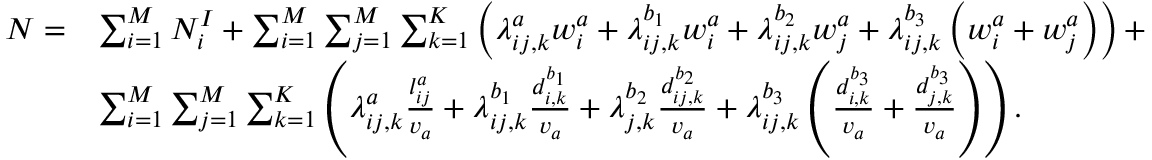Convert formula to latex. <formula><loc_0><loc_0><loc_500><loc_500>\begin{array} { r l } { N = } & { \sum _ { i = 1 } ^ { M } N _ { i } ^ { I } + \sum _ { i = 1 } ^ { M } \sum _ { j = 1 } ^ { M } \sum _ { k = 1 } ^ { K } \left ( \lambda _ { i j , k } ^ { a } w _ { i } ^ { a } + \lambda _ { i j , k } ^ { b _ { 1 } } w _ { i } ^ { a } + \lambda _ { i j , k } ^ { b _ { 2 } } w _ { j } ^ { a } + \lambda _ { i j , k } ^ { b _ { 3 } } \left ( w _ { i } ^ { a } + w _ { j } ^ { a } \right ) \right ) + } \\ & { \sum _ { i = 1 } ^ { M } \sum _ { j = 1 } ^ { M } \sum _ { k = 1 } ^ { K } \left ( \lambda _ { i j , k } ^ { a } \frac { l _ { i j } ^ { a } } { v _ { a } } + \lambda _ { i j , k } ^ { b _ { 1 } } \frac { d _ { i , k } ^ { b _ { 1 } } } { v _ { a } } + \lambda _ { j , k } ^ { b _ { 2 } } \frac { d _ { i j , k } ^ { b _ { 2 } } } { v _ { a } } + \lambda _ { i j , k } ^ { b _ { 3 } } \left ( \frac { d _ { i , k } ^ { b _ { 3 } } } { v _ { a } } + \frac { d _ { j , k } ^ { b _ { 3 } } } { v _ { a } } \right ) \right ) . } \end{array}</formula> 